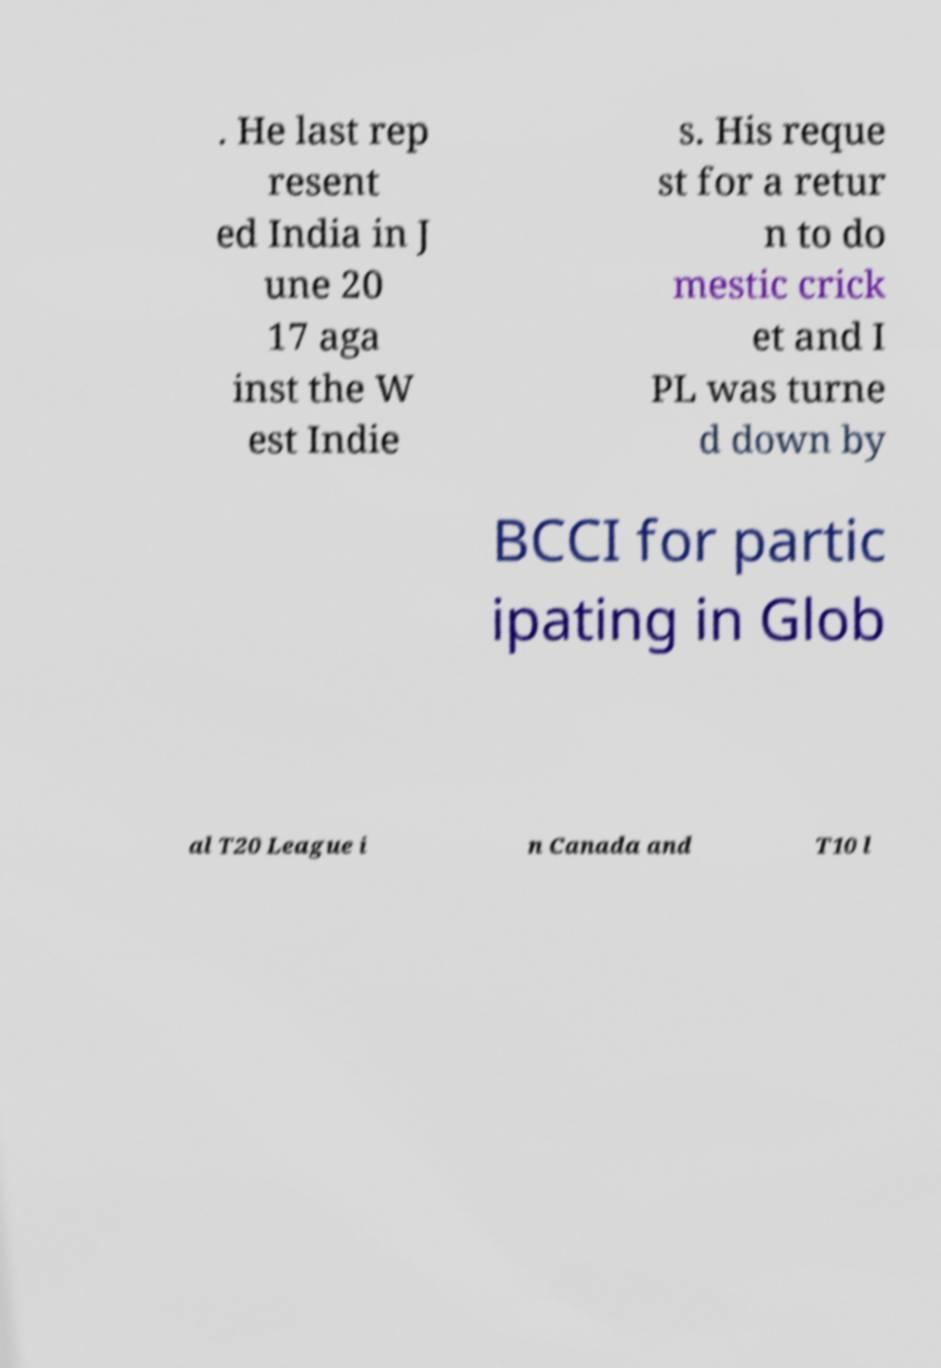Please identify and transcribe the text found in this image. . He last rep resent ed India in J une 20 17 aga inst the W est Indie s. His reque st for a retur n to do mestic crick et and I PL was turne d down by BCCI for partic ipating in Glob al T20 League i n Canada and T10 l 